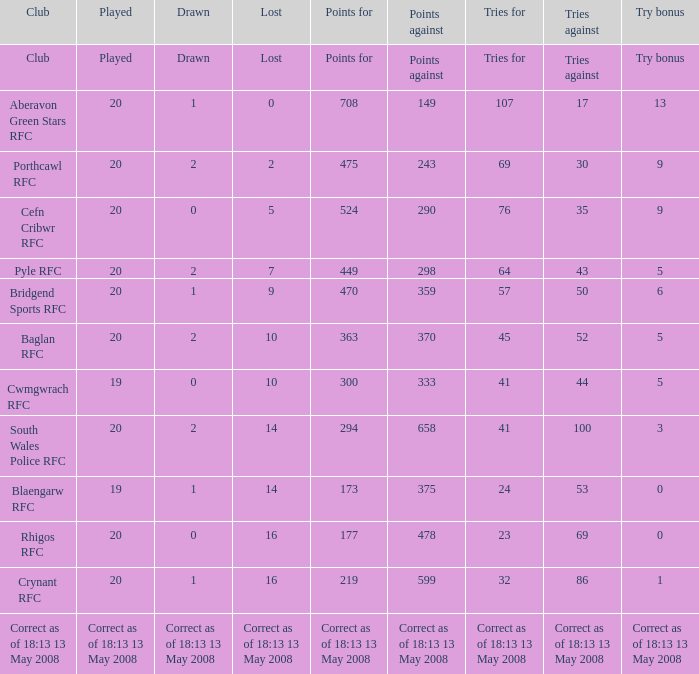How many points are awarded when the try bonus is set to 1? 219.0. 